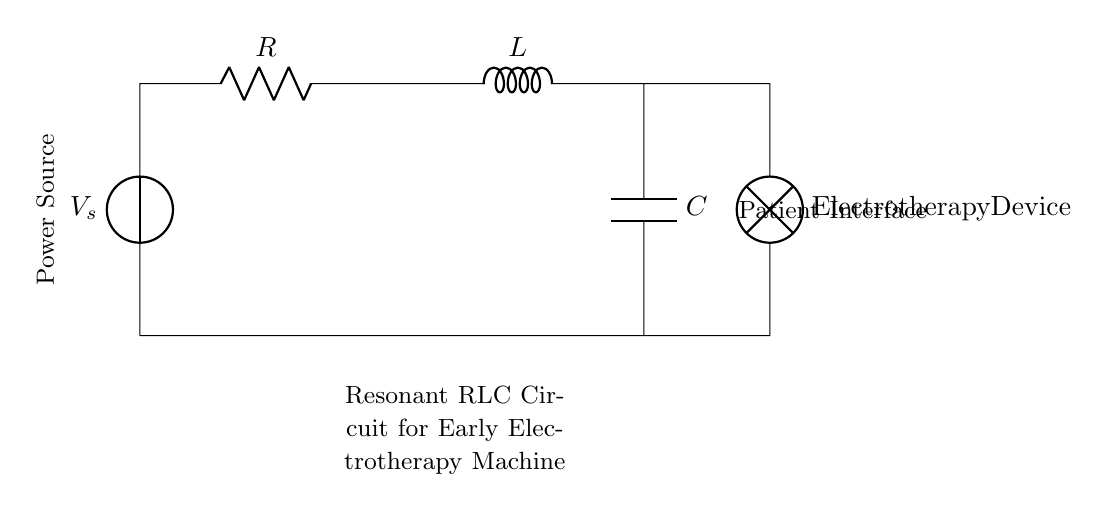What is the type of power source used? The circuit shows a voltage source, indicated by the symbol for a power source, located at the left side.
Answer: Voltage source What components are included in the circuit? The circuit consists of a resistor, inductor, and capacitor, which are indicated by their respective symbols.
Answer: Resistor, Inductor, Capacitor What is connected to the output of the circuit? At the output, there is a lamp labeled as "Electrotherapy Device," connected directly below the components, indicating what the circuit powers.
Answer: Electrotherapy Device What is the function of the inductor in this circuit? The inductor, typically used to store energy in a magnetic field, is important for the resonance in the RLC circuit and affects the overall impedance.
Answer: Store energy How does resonance occur in this RLC circuit? Resonance occurs when the inductive and capacitive reactances are equal, which leads to maximum current flow in the circuit; this condition is typically reached at a specific frequency.
Answer: Equal reactances What happens to the current when the circuit reaches resonance? At resonance, the impedance is minimized and the current reaches its maximum value due to the balance between inductive and capacitive reactance, allowing efficient energy transfer.
Answer: Maximum current What is the role of the resistor in this circuit? The resistor opposes the flow of electric current, affecting the damping of the oscillations and the overall performance of the RLC circuit by converting electrical energy into heat.
Answer: Opposes current 